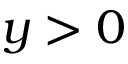Convert formula to latex. <formula><loc_0><loc_0><loc_500><loc_500>y > 0</formula> 